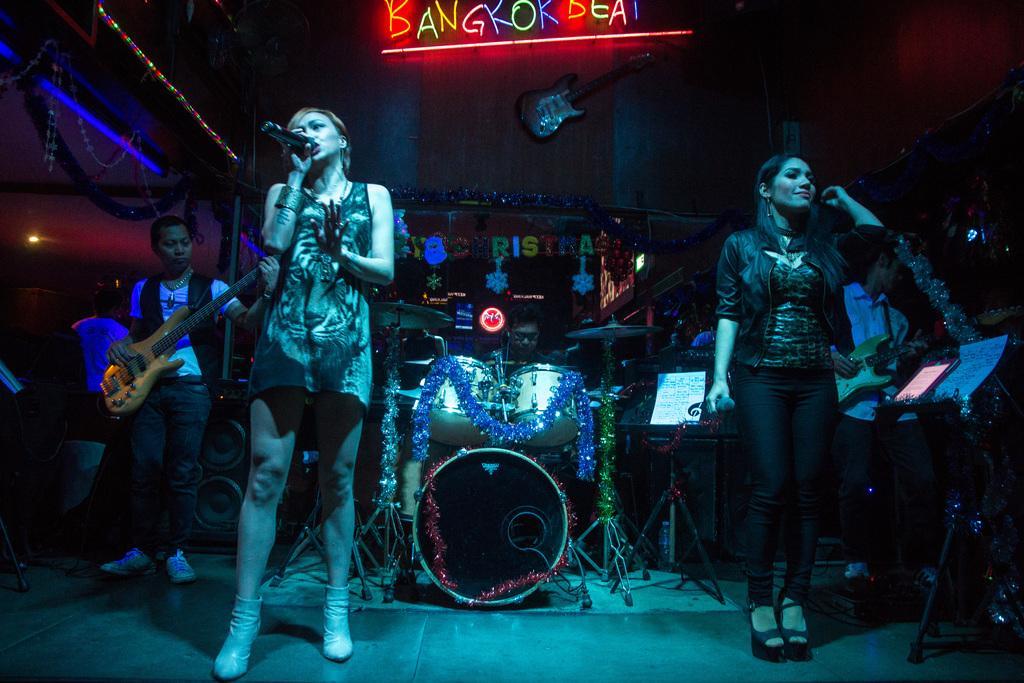In one or two sentences, can you explain what this image depicts? In this image, we can see people and some are holding objects. In the background, we can see musical instruments and there are lights and there are alphabets with lights. At the bottom, there is a floor. 